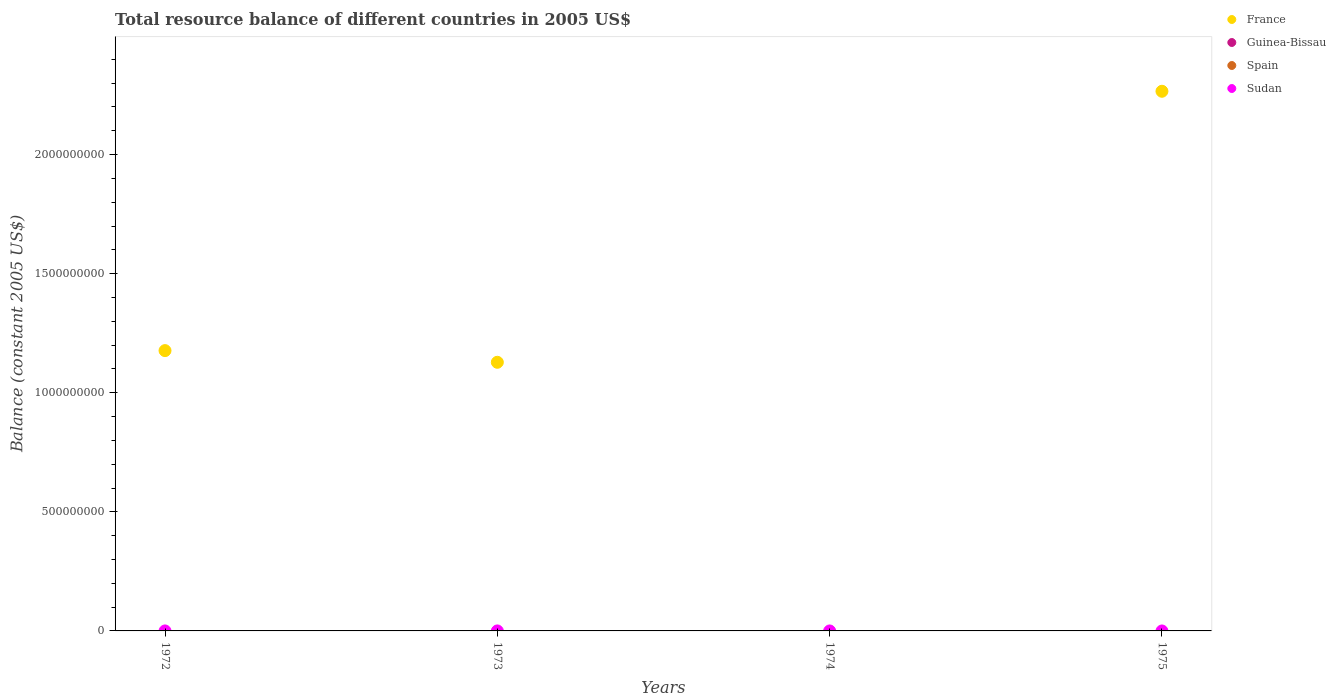What is the total resource balance in France in 1972?
Your answer should be very brief. 1.18e+09. What is the difference between the total resource balance in France in 1973 and that in 1975?
Keep it short and to the point. -1.14e+09. What is the difference between the total resource balance in France in 1975 and the total resource balance in Guinea-Bissau in 1972?
Provide a succinct answer. 2.27e+09. In how many years, is the total resource balance in Spain greater than 1900000000 US$?
Offer a very short reply. 0. What is the ratio of the total resource balance in France in 1972 to that in 1975?
Provide a short and direct response. 0.52. What is the difference between the highest and the second highest total resource balance in France?
Provide a short and direct response. 1.09e+09. What is the difference between the highest and the lowest total resource balance in France?
Provide a succinct answer. 2.27e+09. In how many years, is the total resource balance in Spain greater than the average total resource balance in Spain taken over all years?
Provide a short and direct response. 0. Is the sum of the total resource balance in France in 1972 and 1975 greater than the maximum total resource balance in Spain across all years?
Offer a terse response. Yes. Is it the case that in every year, the sum of the total resource balance in France and total resource balance in Spain  is greater than the total resource balance in Guinea-Bissau?
Your answer should be compact. No. Does the total resource balance in Sudan monotonically increase over the years?
Provide a succinct answer. No. Is the total resource balance in France strictly less than the total resource balance in Sudan over the years?
Give a very brief answer. No. Where does the legend appear in the graph?
Your answer should be very brief. Top right. How are the legend labels stacked?
Ensure brevity in your answer.  Vertical. What is the title of the graph?
Offer a terse response. Total resource balance of different countries in 2005 US$. What is the label or title of the Y-axis?
Provide a short and direct response. Balance (constant 2005 US$). What is the Balance (constant 2005 US$) of France in 1972?
Give a very brief answer. 1.18e+09. What is the Balance (constant 2005 US$) in Guinea-Bissau in 1972?
Your response must be concise. 0. What is the Balance (constant 2005 US$) in Spain in 1972?
Offer a very short reply. 0. What is the Balance (constant 2005 US$) in France in 1973?
Ensure brevity in your answer.  1.13e+09. What is the Balance (constant 2005 US$) in Guinea-Bissau in 1974?
Offer a very short reply. 0. What is the Balance (constant 2005 US$) in Spain in 1974?
Give a very brief answer. 0. What is the Balance (constant 2005 US$) of France in 1975?
Give a very brief answer. 2.27e+09. What is the Balance (constant 2005 US$) of Guinea-Bissau in 1975?
Your answer should be very brief. 0. What is the Balance (constant 2005 US$) of Spain in 1975?
Offer a very short reply. 0. What is the Balance (constant 2005 US$) in Sudan in 1975?
Ensure brevity in your answer.  0. Across all years, what is the maximum Balance (constant 2005 US$) in France?
Provide a short and direct response. 2.27e+09. Across all years, what is the minimum Balance (constant 2005 US$) in France?
Your answer should be compact. 0. What is the total Balance (constant 2005 US$) of France in the graph?
Make the answer very short. 4.57e+09. What is the total Balance (constant 2005 US$) in Spain in the graph?
Offer a very short reply. 0. What is the total Balance (constant 2005 US$) of Sudan in the graph?
Your response must be concise. 0. What is the difference between the Balance (constant 2005 US$) of France in 1972 and that in 1973?
Your response must be concise. 4.90e+07. What is the difference between the Balance (constant 2005 US$) of France in 1972 and that in 1975?
Offer a very short reply. -1.09e+09. What is the difference between the Balance (constant 2005 US$) in France in 1973 and that in 1975?
Offer a terse response. -1.14e+09. What is the average Balance (constant 2005 US$) of France per year?
Provide a short and direct response. 1.14e+09. What is the average Balance (constant 2005 US$) in Guinea-Bissau per year?
Your answer should be compact. 0. What is the ratio of the Balance (constant 2005 US$) of France in 1972 to that in 1973?
Ensure brevity in your answer.  1.04. What is the ratio of the Balance (constant 2005 US$) in France in 1972 to that in 1975?
Ensure brevity in your answer.  0.52. What is the ratio of the Balance (constant 2005 US$) in France in 1973 to that in 1975?
Your answer should be compact. 0.5. What is the difference between the highest and the second highest Balance (constant 2005 US$) in France?
Provide a succinct answer. 1.09e+09. What is the difference between the highest and the lowest Balance (constant 2005 US$) of France?
Your response must be concise. 2.27e+09. 